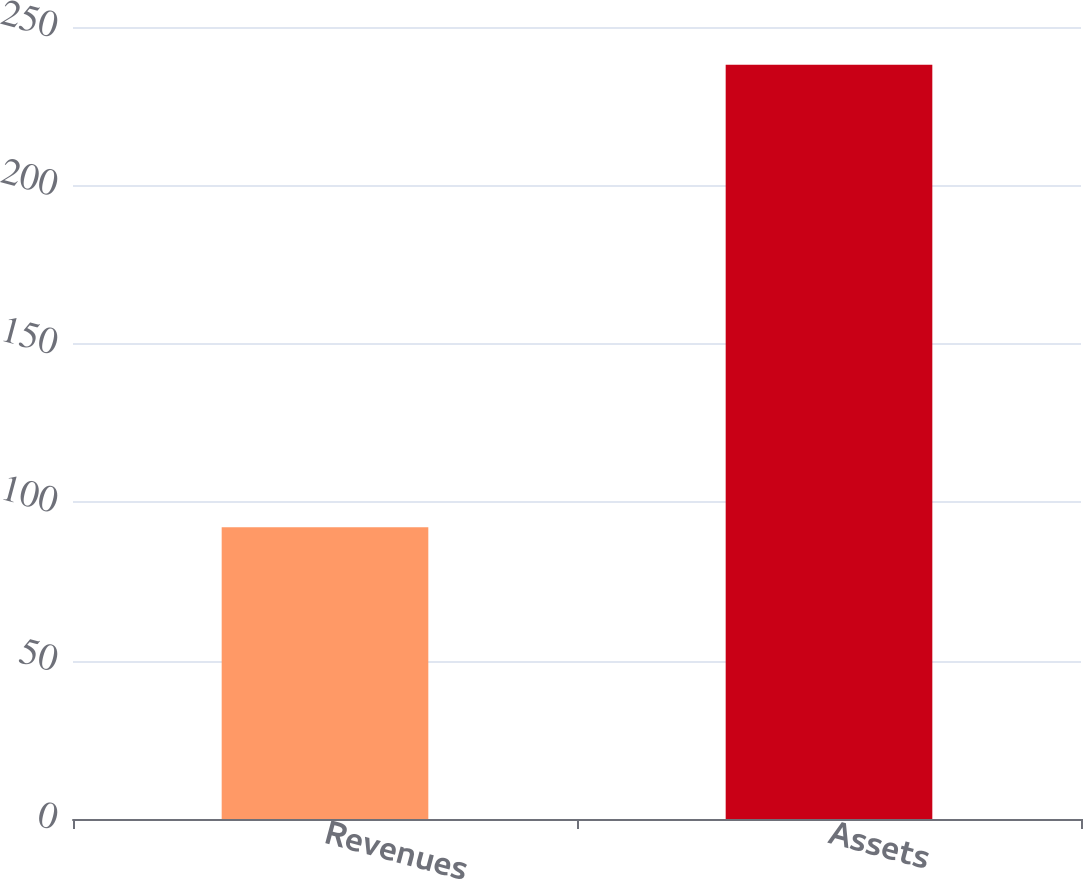Convert chart. <chart><loc_0><loc_0><loc_500><loc_500><bar_chart><fcel>Revenues<fcel>Assets<nl><fcel>92.1<fcel>238.1<nl></chart> 